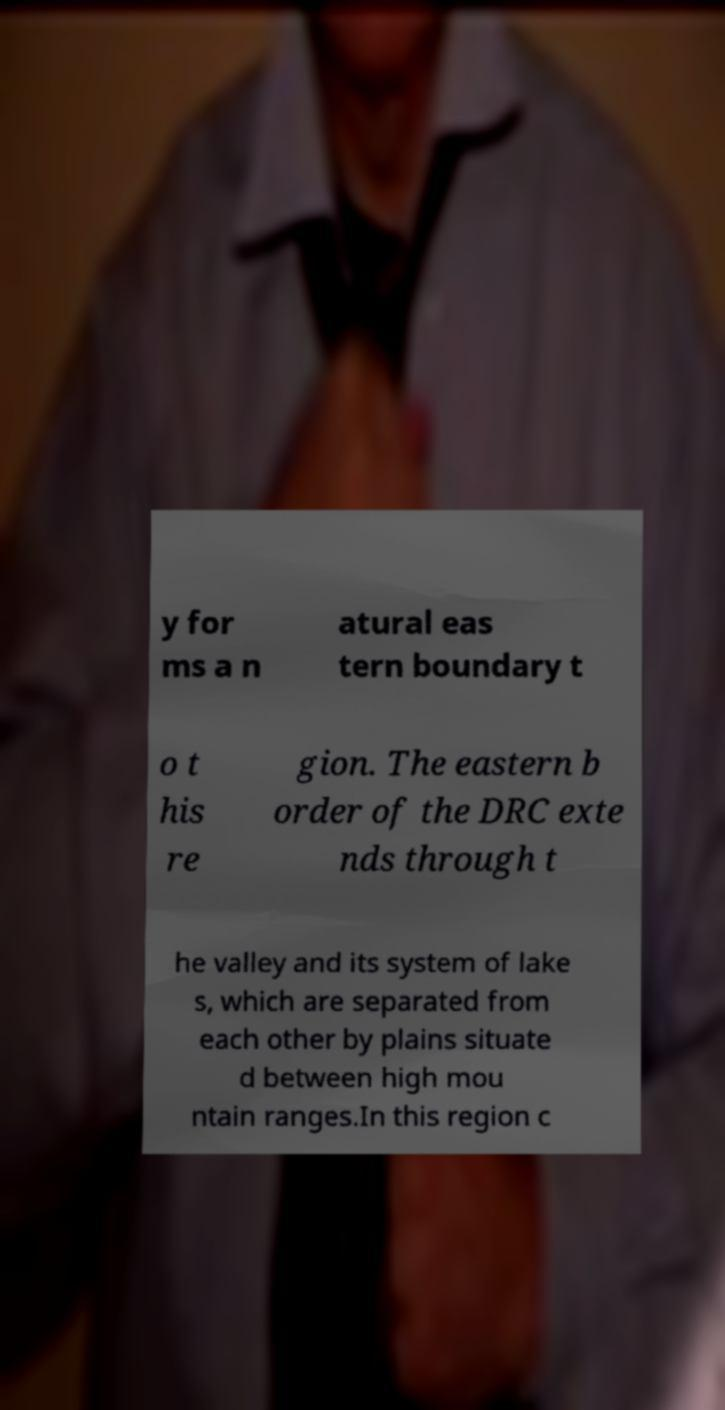What messages or text are displayed in this image? I need them in a readable, typed format. y for ms a n atural eas tern boundary t o t his re gion. The eastern b order of the DRC exte nds through t he valley and its system of lake s, which are separated from each other by plains situate d between high mou ntain ranges.In this region c 